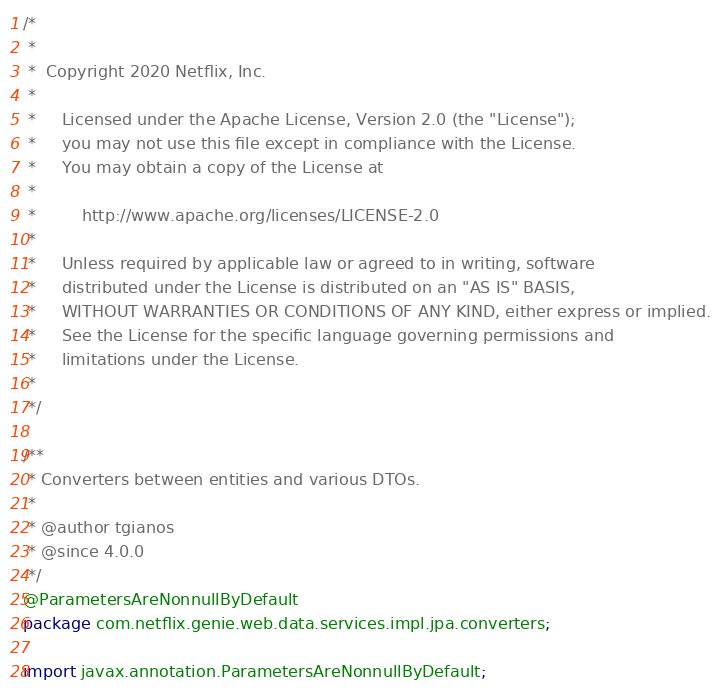<code> <loc_0><loc_0><loc_500><loc_500><_Java_>/*
 *
 *  Copyright 2020 Netflix, Inc.
 *
 *     Licensed under the Apache License, Version 2.0 (the "License");
 *     you may not use this file except in compliance with the License.
 *     You may obtain a copy of the License at
 *
 *         http://www.apache.org/licenses/LICENSE-2.0
 *
 *     Unless required by applicable law or agreed to in writing, software
 *     distributed under the License is distributed on an "AS IS" BASIS,
 *     WITHOUT WARRANTIES OR CONDITIONS OF ANY KIND, either express or implied.
 *     See the License for the specific language governing permissions and
 *     limitations under the License.
 *
 */

/**
 * Converters between entities and various DTOs.
 *
 * @author tgianos
 * @since 4.0.0
 */
@ParametersAreNonnullByDefault
package com.netflix.genie.web.data.services.impl.jpa.converters;

import javax.annotation.ParametersAreNonnullByDefault;
</code> 